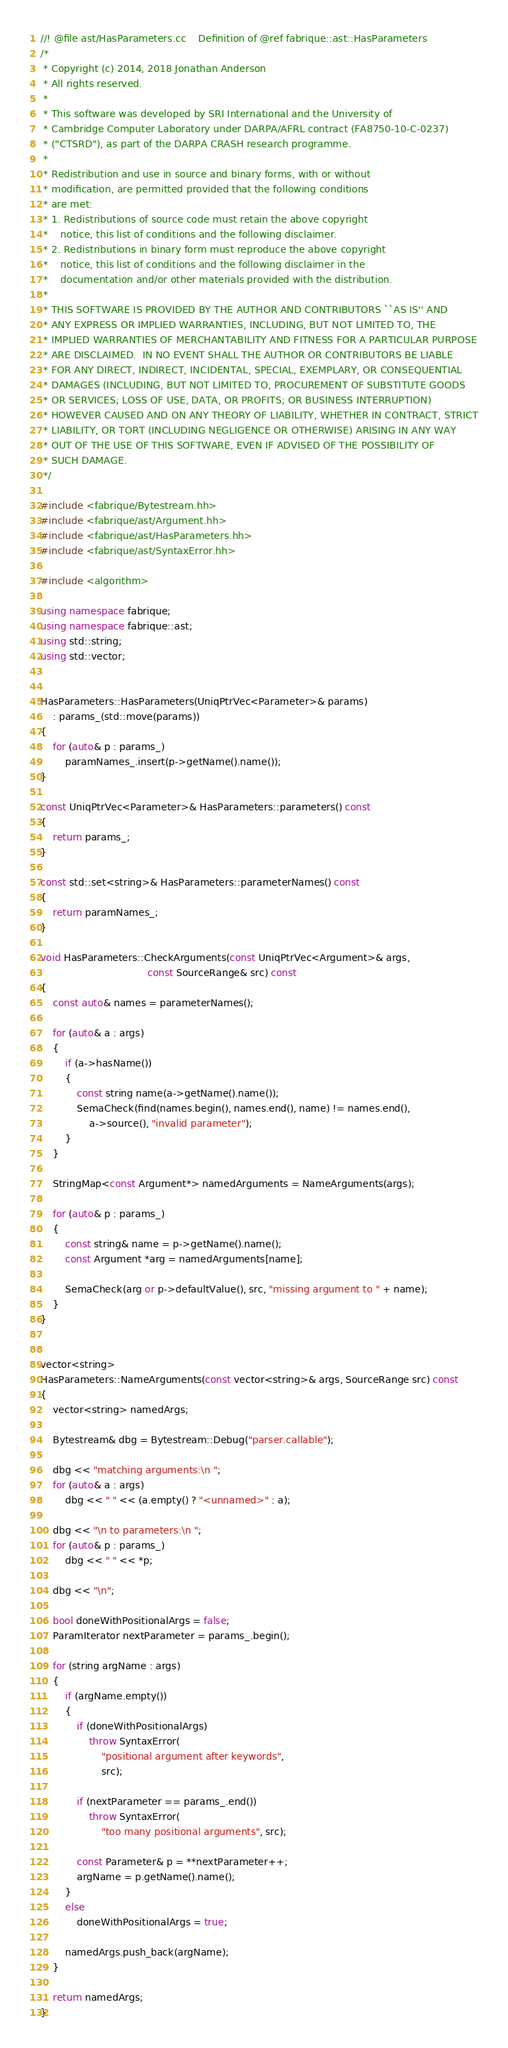Convert code to text. <code><loc_0><loc_0><loc_500><loc_500><_C++_>//! @file ast/HasParameters.cc    Definition of @ref fabrique::ast::HasParameters
/*
 * Copyright (c) 2014, 2018 Jonathan Anderson
 * All rights reserved.
 *
 * This software was developed by SRI International and the University of
 * Cambridge Computer Laboratory under DARPA/AFRL contract (FA8750-10-C-0237)
 * ("CTSRD"), as part of the DARPA CRASH research programme.
 *
 * Redistribution and use in source and binary forms, with or without
 * modification, are permitted provided that the following conditions
 * are met:
 * 1. Redistributions of source code must retain the above copyright
 *    notice, this list of conditions and the following disclaimer.
 * 2. Redistributions in binary form must reproduce the above copyright
 *    notice, this list of conditions and the following disclaimer in the
 *    documentation and/or other materials provided with the distribution.
 *
 * THIS SOFTWARE IS PROVIDED BY THE AUTHOR AND CONTRIBUTORS ``AS IS'' AND
 * ANY EXPRESS OR IMPLIED WARRANTIES, INCLUDING, BUT NOT LIMITED TO, THE
 * IMPLIED WARRANTIES OF MERCHANTABILITY AND FITNESS FOR A PARTICULAR PURPOSE
 * ARE DISCLAIMED.  IN NO EVENT SHALL THE AUTHOR OR CONTRIBUTORS BE LIABLE
 * FOR ANY DIRECT, INDIRECT, INCIDENTAL, SPECIAL, EXEMPLARY, OR CONSEQUENTIAL
 * DAMAGES (INCLUDING, BUT NOT LIMITED TO, PROCUREMENT OF SUBSTITUTE GOODS
 * OR SERVICES; LOSS OF USE, DATA, OR PROFITS; OR BUSINESS INTERRUPTION)
 * HOWEVER CAUSED AND ON ANY THEORY OF LIABILITY, WHETHER IN CONTRACT, STRICT
 * LIABILITY, OR TORT (INCLUDING NEGLIGENCE OR OTHERWISE) ARISING IN ANY WAY
 * OUT OF THE USE OF THIS SOFTWARE, EVEN IF ADVISED OF THE POSSIBILITY OF
 * SUCH DAMAGE.
 */

#include <fabrique/Bytestream.hh>
#include <fabrique/ast/Argument.hh>
#include <fabrique/ast/HasParameters.hh>
#include <fabrique/ast/SyntaxError.hh>

#include <algorithm>

using namespace fabrique;
using namespace fabrique::ast;
using std::string;
using std::vector;


HasParameters::HasParameters(UniqPtrVec<Parameter>& params)
	: params_(std::move(params))
{
	for (auto& p : params_)
		paramNames_.insert(p->getName().name());
}

const UniqPtrVec<Parameter>& HasParameters::parameters() const
{
	return params_;
}

const std::set<string>& HasParameters::parameterNames() const
{
	return paramNames_;
}

void HasParameters::CheckArguments(const UniqPtrVec<Argument>& args,
                                   const SourceRange& src) const
{
	const auto& names = parameterNames();

	for (auto& a : args)
	{
		if (a->hasName())
		{
			const string name(a->getName().name());
			SemaCheck(find(names.begin(), names.end(), name) != names.end(),
				a->source(), "invalid parameter");
		}
	}

	StringMap<const Argument*> namedArguments = NameArguments(args);

	for (auto& p : params_)
	{
		const string& name = p->getName().name();
		const Argument *arg = namedArguments[name];

		SemaCheck(arg or p->defaultValue(), src, "missing argument to " + name);
	}
}


vector<string>
HasParameters::NameArguments(const vector<string>& args, SourceRange src) const
{
	vector<string> namedArgs;

	Bytestream& dbg = Bytestream::Debug("parser.callable");

	dbg << "matching arguments:\n ";
	for (auto& a : args)
		dbg << " " << (a.empty() ? "<unnamed>" : a);

	dbg << "\n to parameters:\n ";
	for (auto& p : params_)
		dbg << " " << *p;

	dbg << "\n";

	bool doneWithPositionalArgs = false;
	ParamIterator nextParameter = params_.begin();

	for (string argName : args)
	{
		if (argName.empty())
		{
			if (doneWithPositionalArgs)
				throw SyntaxError(
					"positional argument after keywords",
					src);

			if (nextParameter == params_.end())
				throw SyntaxError(
					"too many positional arguments", src);

			const Parameter& p = **nextParameter++;
			argName = p.getName().name();
		}
		else
			doneWithPositionalArgs = true;

		namedArgs.push_back(argName);
	}

	return namedArgs;
}
</code> 